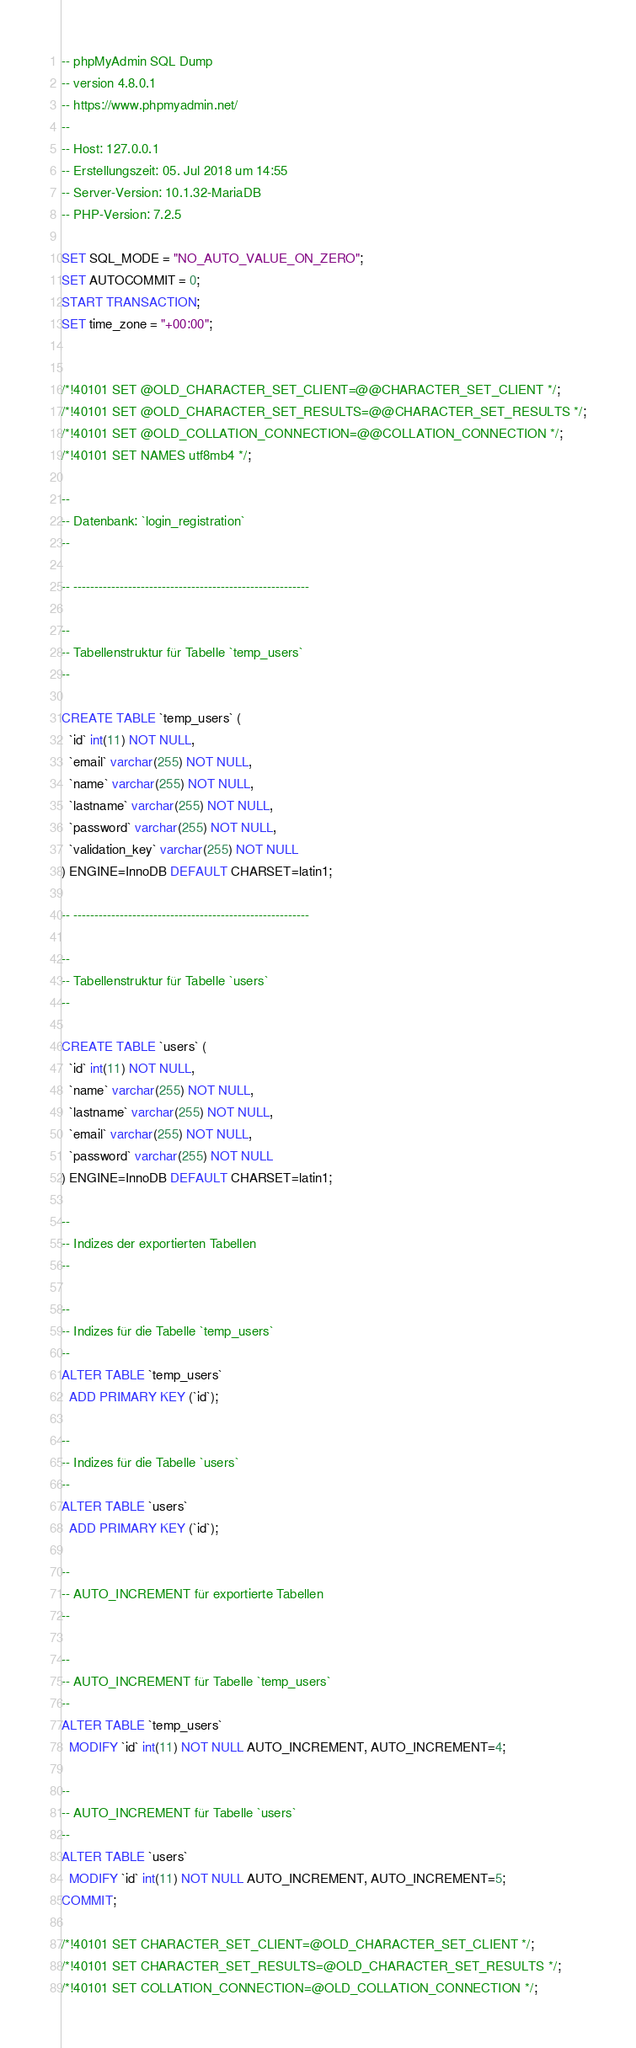<code> <loc_0><loc_0><loc_500><loc_500><_SQL_>-- phpMyAdmin SQL Dump
-- version 4.8.0.1
-- https://www.phpmyadmin.net/
--
-- Host: 127.0.0.1
-- Erstellungszeit: 05. Jul 2018 um 14:55
-- Server-Version: 10.1.32-MariaDB
-- PHP-Version: 7.2.5

SET SQL_MODE = "NO_AUTO_VALUE_ON_ZERO";
SET AUTOCOMMIT = 0;
START TRANSACTION;
SET time_zone = "+00:00";


/*!40101 SET @OLD_CHARACTER_SET_CLIENT=@@CHARACTER_SET_CLIENT */;
/*!40101 SET @OLD_CHARACTER_SET_RESULTS=@@CHARACTER_SET_RESULTS */;
/*!40101 SET @OLD_COLLATION_CONNECTION=@@COLLATION_CONNECTION */;
/*!40101 SET NAMES utf8mb4 */;

--
-- Datenbank: `login_registration`
--

-- --------------------------------------------------------

--
-- Tabellenstruktur für Tabelle `temp_users`
--

CREATE TABLE `temp_users` (
  `id` int(11) NOT NULL,
  `email` varchar(255) NOT NULL,
  `name` varchar(255) NOT NULL,
  `lastname` varchar(255) NOT NULL,
  `password` varchar(255) NOT NULL,
  `validation_key` varchar(255) NOT NULL
) ENGINE=InnoDB DEFAULT CHARSET=latin1;

-- --------------------------------------------------------

--
-- Tabellenstruktur für Tabelle `users`
--

CREATE TABLE `users` (
  `id` int(11) NOT NULL,
  `name` varchar(255) NOT NULL,
  `lastname` varchar(255) NOT NULL,
  `email` varchar(255) NOT NULL,
  `password` varchar(255) NOT NULL
) ENGINE=InnoDB DEFAULT CHARSET=latin1;

--
-- Indizes der exportierten Tabellen
--

--
-- Indizes für die Tabelle `temp_users`
--
ALTER TABLE `temp_users`
  ADD PRIMARY KEY (`id`);

--
-- Indizes für die Tabelle `users`
--
ALTER TABLE `users`
  ADD PRIMARY KEY (`id`);

--
-- AUTO_INCREMENT für exportierte Tabellen
--

--
-- AUTO_INCREMENT für Tabelle `temp_users`
--
ALTER TABLE `temp_users`
  MODIFY `id` int(11) NOT NULL AUTO_INCREMENT, AUTO_INCREMENT=4;

--
-- AUTO_INCREMENT für Tabelle `users`
--
ALTER TABLE `users`
  MODIFY `id` int(11) NOT NULL AUTO_INCREMENT, AUTO_INCREMENT=5;
COMMIT;

/*!40101 SET CHARACTER_SET_CLIENT=@OLD_CHARACTER_SET_CLIENT */;
/*!40101 SET CHARACTER_SET_RESULTS=@OLD_CHARACTER_SET_RESULTS */;
/*!40101 SET COLLATION_CONNECTION=@OLD_COLLATION_CONNECTION */;
</code> 